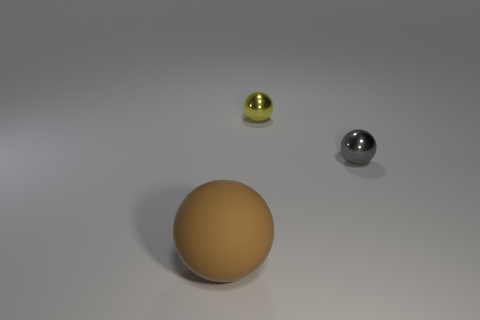Subtract all matte balls. How many balls are left? 2 Add 3 tiny gray matte objects. How many objects exist? 6 Subtract all gray spheres. How many spheres are left? 2 Subtract 0 yellow cylinders. How many objects are left? 3 Subtract 2 spheres. How many spheres are left? 1 Subtract all blue balls. Subtract all green cylinders. How many balls are left? 3 Subtract all purple blocks. How many gray spheres are left? 1 Subtract all small brown rubber spheres. Subtract all small things. How many objects are left? 1 Add 3 large brown matte objects. How many large brown matte objects are left? 4 Add 1 tiny yellow objects. How many tiny yellow objects exist? 2 